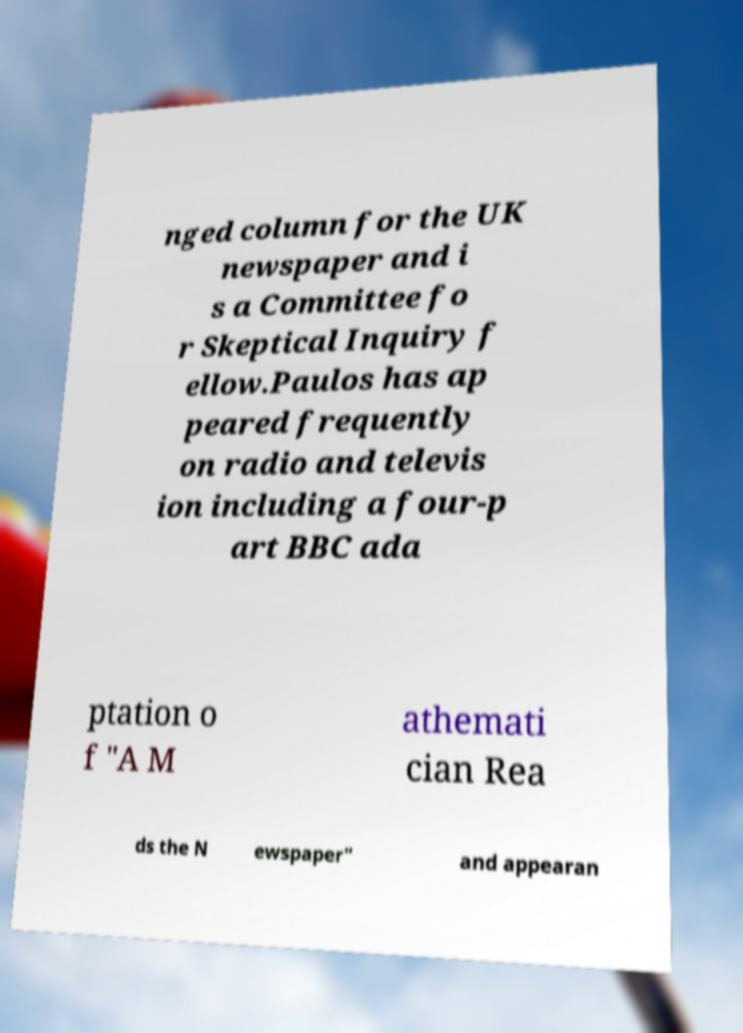Could you extract and type out the text from this image? nged column for the UK newspaper and i s a Committee fo r Skeptical Inquiry f ellow.Paulos has ap peared frequently on radio and televis ion including a four-p art BBC ada ptation o f "A M athemati cian Rea ds the N ewspaper" and appearan 